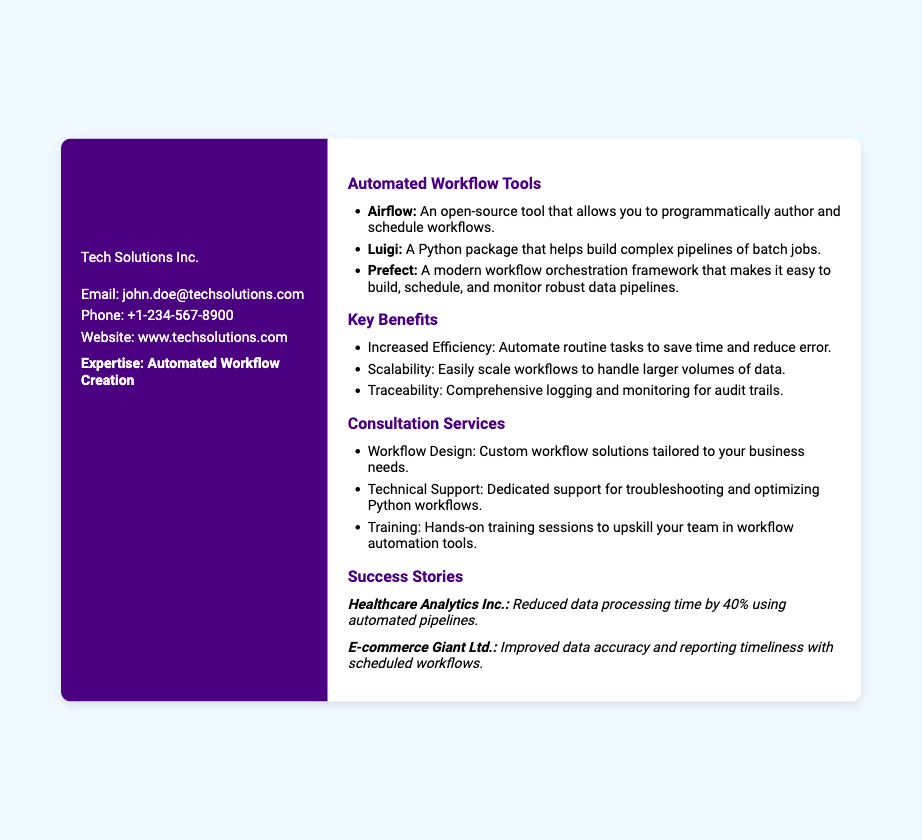What is the name of the individual on the card? The name of the individual is displayed prominently at the top of the card.
Answer: John Doe What is the role of John Doe? The role is stated immediately after the name in a larger font.
Answer: Python Technical Support Specialist What is the company’s name? The company name follows the job title and specifies where John works.
Answer: Tech Solutions Inc What is the contact email provided? The contact email is clearly listed in the contact information section.
Answer: john.doe@techsolutions.com What are the three automated workflow tools mentioned? The workflow tools are listed in a bullet format under the corresponding section.
Answer: Airflow, Luigi, Prefect What is one key benefit mentioned in the document? The benefits of automated workflows are listed in a bullet format.
Answer: Increased Efficiency What type of services does John Doe offer? The services are outlined in a separate section with bullet points.
Answer: Consultation Services Which successful company is mentioned in the success stories? The success stories include specific companies that benefitted from the services.
Answer: Healthcare Analytics Inc What percentage reduction in data processing time is reported for Healthcare Analytics Inc.? The percentage is explicitly stated in the success story section.
Answer: 40% 